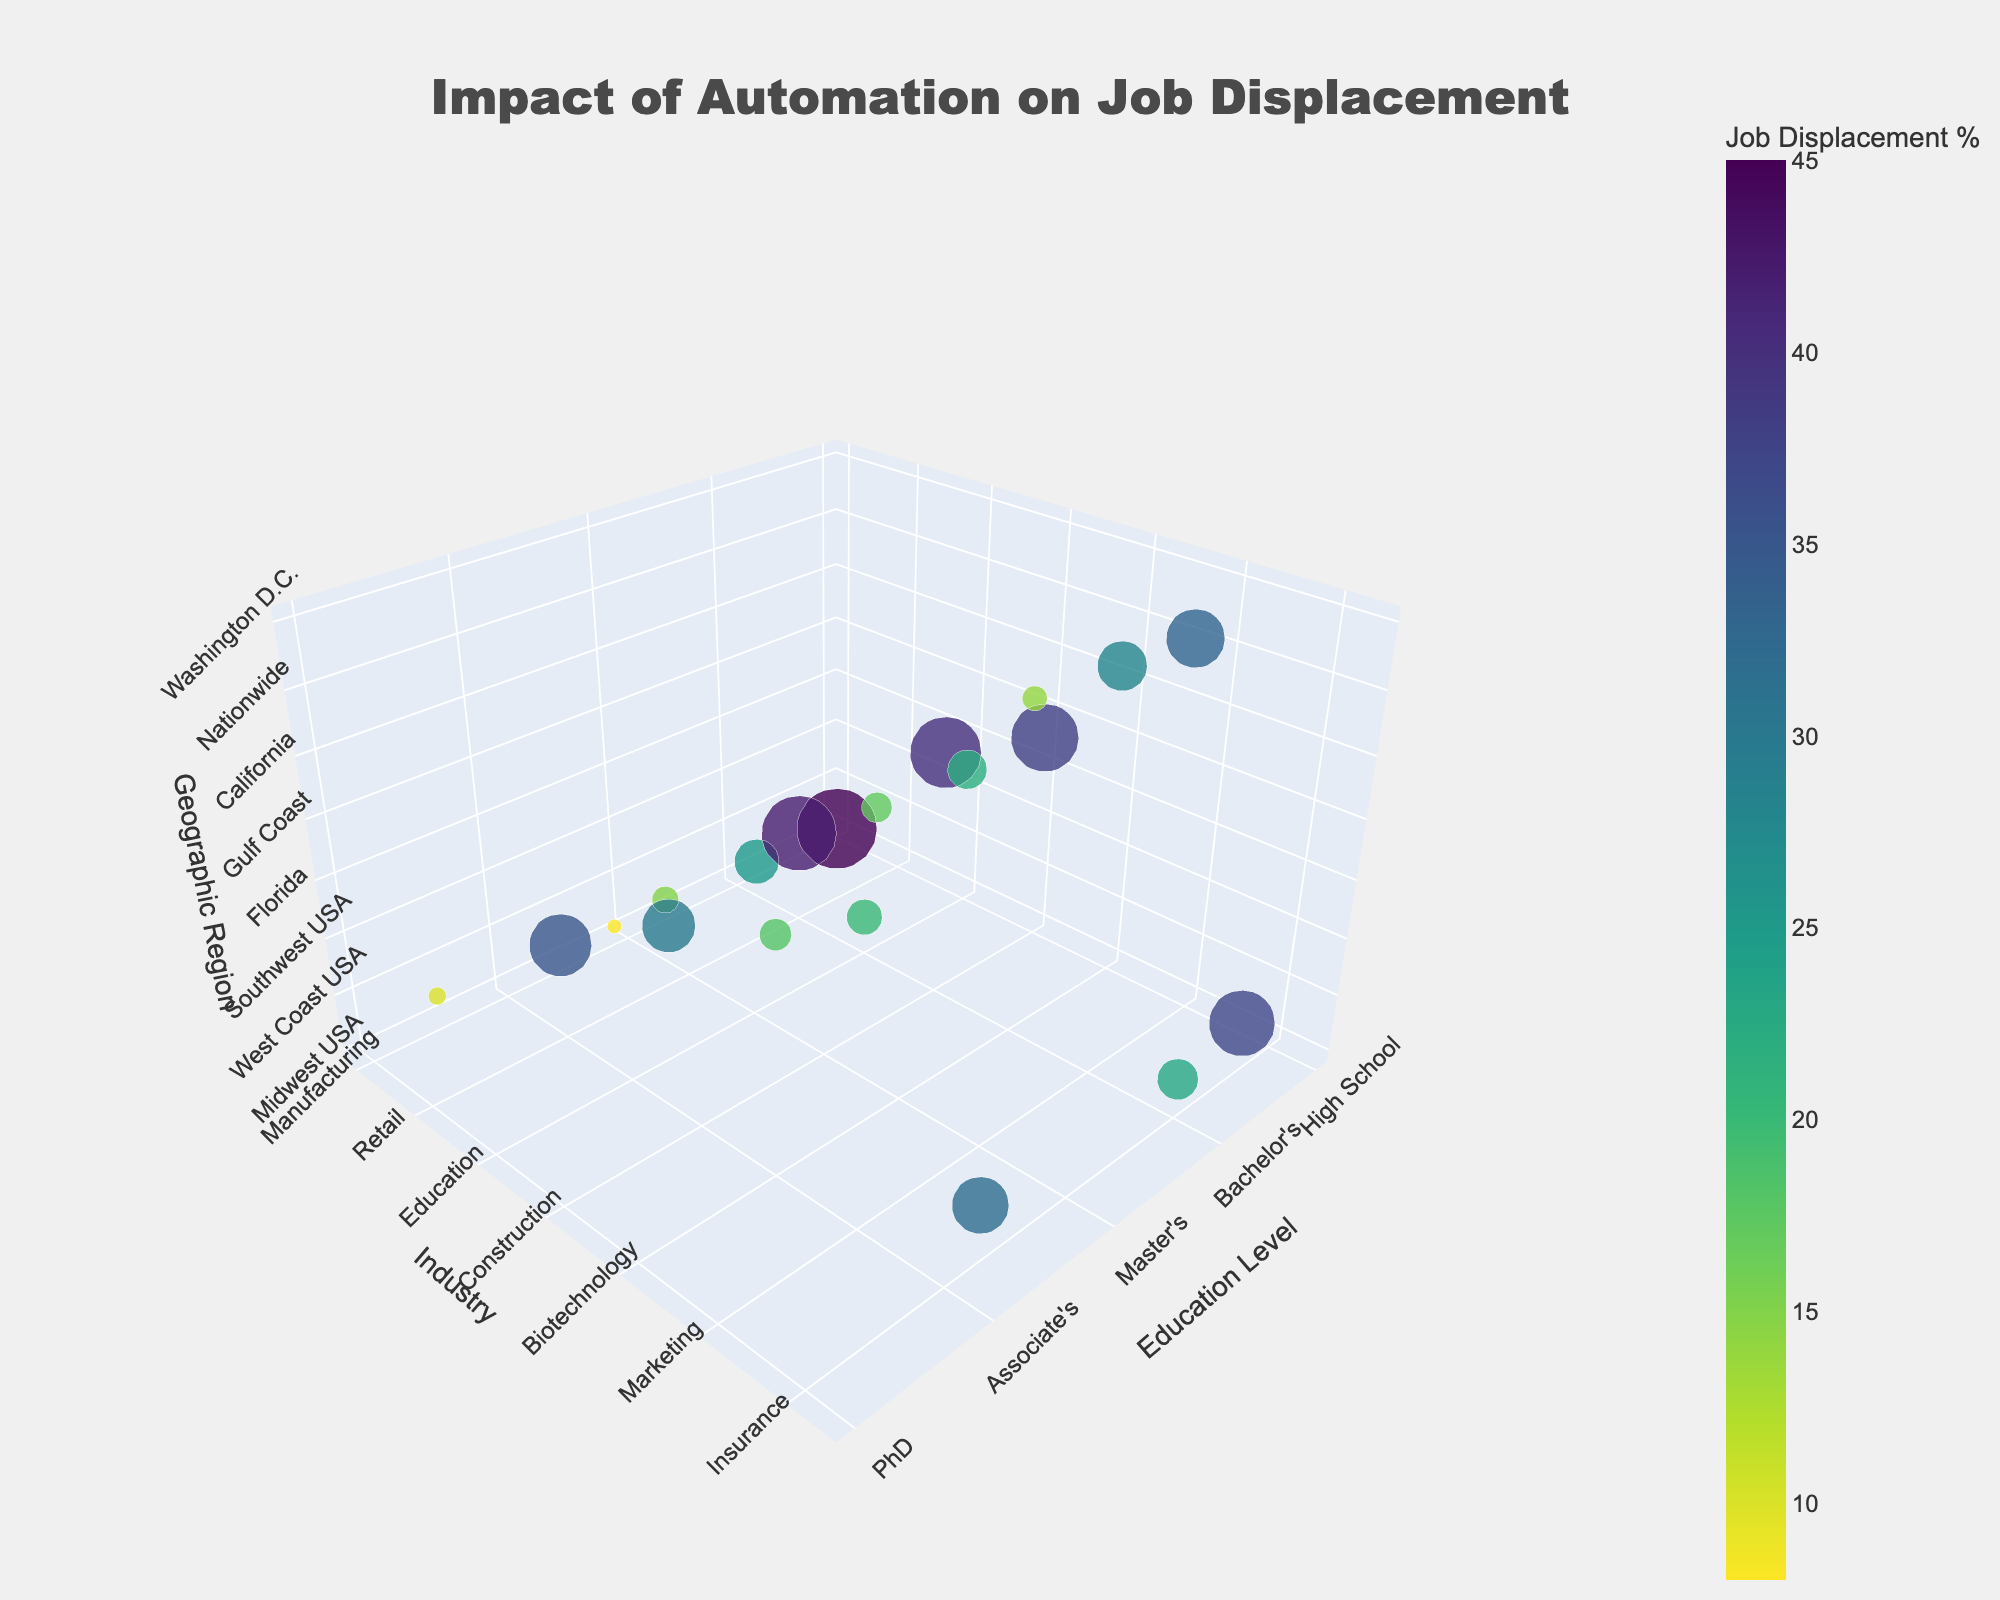what's the title of the figure? The title is usually displayed at the top of the figure and summarizes the main topic being visualized. In this case, it should clearly state the focus on the impact of automation on job displacement.
Answer: Impact of Automation on Job Displacement which geographic region shows the highest job displacement percentage for high school education level? To answer this, locate the points representing the high school education level on the x-axis, then check the different geographic regions for these points and identify the one with the highest job displacement percentage.
Answer: Midwest USA compare the job displacement percentages between Bachelor's degree in Finance and Master's degree in Technology Locate points for Bachelor's degree in Finance and Master's degree in Technology on the graph by checking their y-axis values for "Finance" and "Technology,” respectively. Then compare their corresponding job displacement percentages.
Answer: 25% vs 15% what is the color range used for indicating job displacement percentage? The color range is typically shown in the colorbar legend of the figure, which helps indicate different values through a color gradient. In this case, it uses a reverse sequential Viridis color scale.
Answer: Viridis what is the total number of data points represented in the figure? By visually scanning the figure and counting the number of distinct markers or points shown in the 3D scatter plot, you can determine the total number of data points.
Answer: 20 which industry has the lowest job displacement percentage, and what is the percentage? From the plot, find the industry with the lowest positioned marker on the color gradient or scale. Hovering over the point can provide exact values.
Answer: Biotechnology, 8% which education level-industry pair shows a higher job displacement percentage: Associate's in Automotive or Associate's in Hospitality? Find the markers for "Associate's" in the Automotive and Hospitality industries by referencing the y-axis values, then compare their job displacement percentages indicated by marker size or hover text.
Answer: Automotive, 42% what is the trend in job displacement percentages with increasing education levels in the Technology industry? Identify the points for the Technology industry throughout different education levels and analyze the associated job displacement percentages for any observable trend.
Answer: Decreasing how does the job displacement percentage in the Midwest compare between Manufacturing and Logistics for high school education level? First, identify the points for Manufacturing and Logistics under the high school education level in the Midwest. Then, compare the job displacement percentages shown by each point.
Answer: 45% vs 37% in which geographic region does Master's degree in Aerospace show job displacement, and what is the percentage? Locate the point that corresponds to a Master's degree in Aerospace on the graph, then refer to the z-axis to identify its geographic region and check the job displacement percentage through hover text.
Answer: Southeast USA, 18% 